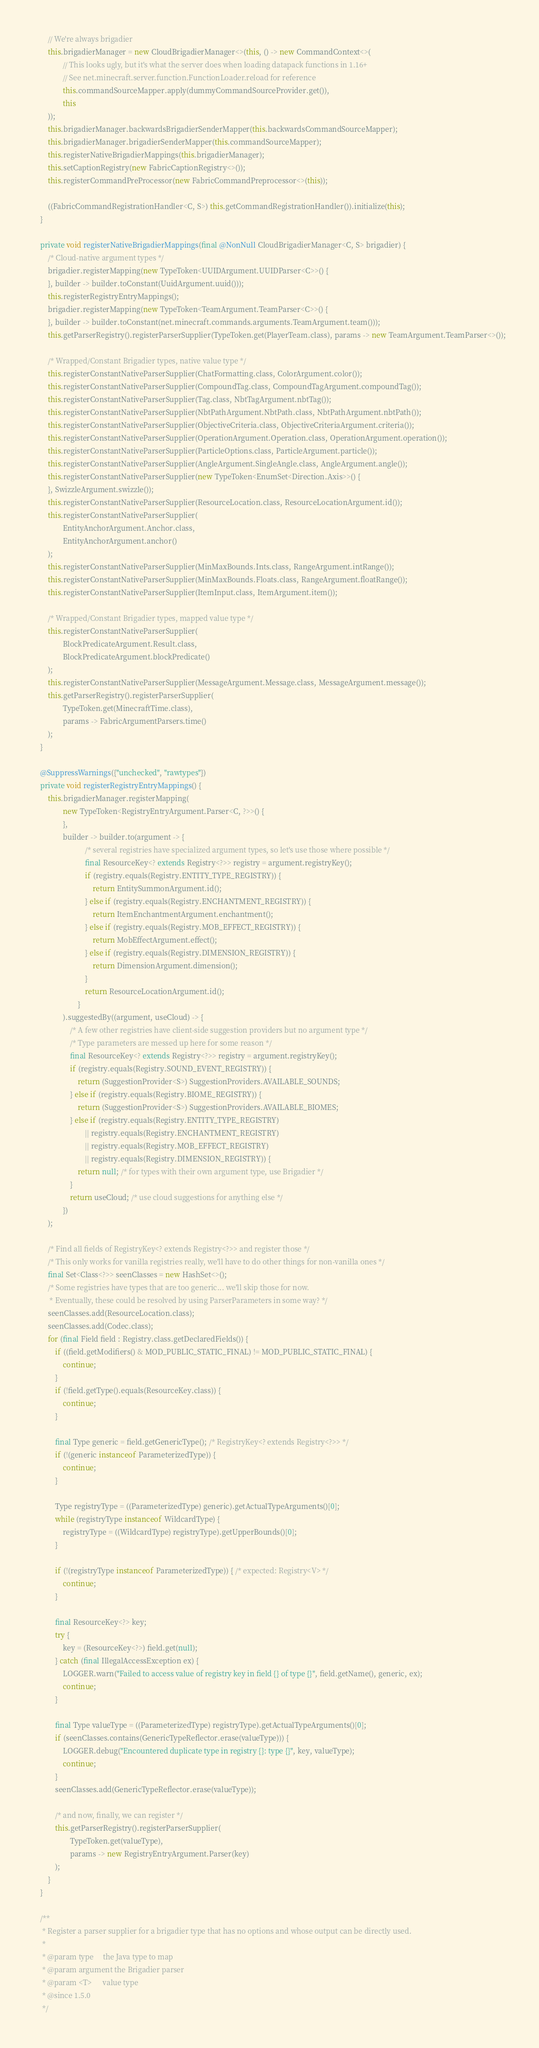Convert code to text. <code><loc_0><loc_0><loc_500><loc_500><_Java_>
        // We're always brigadier
        this.brigadierManager = new CloudBrigadierManager<>(this, () -> new CommandContext<>(
                // This looks ugly, but it's what the server does when loading datapack functions in 1.16+
                // See net.minecraft.server.function.FunctionLoader.reload for reference
                this.commandSourceMapper.apply(dummyCommandSourceProvider.get()),
                this
        ));
        this.brigadierManager.backwardsBrigadierSenderMapper(this.backwardsCommandSourceMapper);
        this.brigadierManager.brigadierSenderMapper(this.commandSourceMapper);
        this.registerNativeBrigadierMappings(this.brigadierManager);
        this.setCaptionRegistry(new FabricCaptionRegistry<>());
        this.registerCommandPreProcessor(new FabricCommandPreprocessor<>(this));

        ((FabricCommandRegistrationHandler<C, S>) this.getCommandRegistrationHandler()).initialize(this);
    }

    private void registerNativeBrigadierMappings(final @NonNull CloudBrigadierManager<C, S> brigadier) {
        /* Cloud-native argument types */
        brigadier.registerMapping(new TypeToken<UUIDArgument.UUIDParser<C>>() {
        }, builder -> builder.toConstant(UuidArgument.uuid()));
        this.registerRegistryEntryMappings();
        brigadier.registerMapping(new TypeToken<TeamArgument.TeamParser<C>>() {
        }, builder -> builder.toConstant(net.minecraft.commands.arguments.TeamArgument.team()));
        this.getParserRegistry().registerParserSupplier(TypeToken.get(PlayerTeam.class), params -> new TeamArgument.TeamParser<>());

        /* Wrapped/Constant Brigadier types, native value type */
        this.registerConstantNativeParserSupplier(ChatFormatting.class, ColorArgument.color());
        this.registerConstantNativeParserSupplier(CompoundTag.class, CompoundTagArgument.compoundTag());
        this.registerConstantNativeParserSupplier(Tag.class, NbtTagArgument.nbtTag());
        this.registerConstantNativeParserSupplier(NbtPathArgument.NbtPath.class, NbtPathArgument.nbtPath());
        this.registerConstantNativeParserSupplier(ObjectiveCriteria.class, ObjectiveCriteriaArgument.criteria());
        this.registerConstantNativeParserSupplier(OperationArgument.Operation.class, OperationArgument.operation());
        this.registerConstantNativeParserSupplier(ParticleOptions.class, ParticleArgument.particle());
        this.registerConstantNativeParserSupplier(AngleArgument.SingleAngle.class, AngleArgument.angle());
        this.registerConstantNativeParserSupplier(new TypeToken<EnumSet<Direction.Axis>>() {
        }, SwizzleArgument.swizzle());
        this.registerConstantNativeParserSupplier(ResourceLocation.class, ResourceLocationArgument.id());
        this.registerConstantNativeParserSupplier(
                EntityAnchorArgument.Anchor.class,
                EntityAnchorArgument.anchor()
        );
        this.registerConstantNativeParserSupplier(MinMaxBounds.Ints.class, RangeArgument.intRange());
        this.registerConstantNativeParserSupplier(MinMaxBounds.Floats.class, RangeArgument.floatRange());
        this.registerConstantNativeParserSupplier(ItemInput.class, ItemArgument.item());

        /* Wrapped/Constant Brigadier types, mapped value type */
        this.registerConstantNativeParserSupplier(
                BlockPredicateArgument.Result.class,
                BlockPredicateArgument.blockPredicate()
        );
        this.registerConstantNativeParserSupplier(MessageArgument.Message.class, MessageArgument.message());
        this.getParserRegistry().registerParserSupplier(
                TypeToken.get(MinecraftTime.class),
                params -> FabricArgumentParsers.time()
        );
    }

    @SuppressWarnings({"unchecked", "rawtypes"})
    private void registerRegistryEntryMappings() {
        this.brigadierManager.registerMapping(
                new TypeToken<RegistryEntryArgument.Parser<C, ?>>() {
                },
                builder -> builder.to(argument -> {
                            /* several registries have specialized argument types, so let's use those where possible */
                            final ResourceKey<? extends Registry<?>> registry = argument.registryKey();
                            if (registry.equals(Registry.ENTITY_TYPE_REGISTRY)) {
                                return EntitySummonArgument.id();
                            } else if (registry.equals(Registry.ENCHANTMENT_REGISTRY)) {
                                return ItemEnchantmentArgument.enchantment();
                            } else if (registry.equals(Registry.MOB_EFFECT_REGISTRY)) {
                                return MobEffectArgument.effect();
                            } else if (registry.equals(Registry.DIMENSION_REGISTRY)) {
                                return DimensionArgument.dimension();
                            }
                            return ResourceLocationArgument.id();
                        }
                ).suggestedBy((argument, useCloud) -> {
                    /* A few other registries have client-side suggestion providers but no argument type */
                    /* Type parameters are messed up here for some reason */
                    final ResourceKey<? extends Registry<?>> registry = argument.registryKey();
                    if (registry.equals(Registry.SOUND_EVENT_REGISTRY)) {
                        return (SuggestionProvider<S>) SuggestionProviders.AVAILABLE_SOUNDS;
                    } else if (registry.equals(Registry.BIOME_REGISTRY)) {
                        return (SuggestionProvider<S>) SuggestionProviders.AVAILABLE_BIOMES;
                    } else if (registry.equals(Registry.ENTITY_TYPE_REGISTRY)
                            || registry.equals(Registry.ENCHANTMENT_REGISTRY)
                            || registry.equals(Registry.MOB_EFFECT_REGISTRY)
                            || registry.equals(Registry.DIMENSION_REGISTRY)) {
                        return null; /* for types with their own argument type, use Brigadier */
                    }
                    return useCloud; /* use cloud suggestions for anything else */
                })
        );

        /* Find all fields of RegistryKey<? extends Registry<?>> and register those */
        /* This only works for vanilla registries really, we'll have to do other things for non-vanilla ones */
        final Set<Class<?>> seenClasses = new HashSet<>();
        /* Some registries have types that are too generic... we'll skip those for now.
         * Eventually, these could be resolved by using ParserParameters in some way? */
        seenClasses.add(ResourceLocation.class);
        seenClasses.add(Codec.class);
        for (final Field field : Registry.class.getDeclaredFields()) {
            if ((field.getModifiers() & MOD_PUBLIC_STATIC_FINAL) != MOD_PUBLIC_STATIC_FINAL) {
                continue;
            }
            if (!field.getType().equals(ResourceKey.class)) {
                continue;
            }

            final Type generic = field.getGenericType(); /* RegistryKey<? extends Registry<?>> */
            if (!(generic instanceof ParameterizedType)) {
                continue;
            }

            Type registryType = ((ParameterizedType) generic).getActualTypeArguments()[0];
            while (registryType instanceof WildcardType) {
                registryType = ((WildcardType) registryType).getUpperBounds()[0];
            }

            if (!(registryType instanceof ParameterizedType)) { /* expected: Registry<V> */
                continue;
            }

            final ResourceKey<?> key;
            try {
                key = (ResourceKey<?>) field.get(null);
            } catch (final IllegalAccessException ex) {
                LOGGER.warn("Failed to access value of registry key in field {} of type {}", field.getName(), generic, ex);
                continue;
            }

            final Type valueType = ((ParameterizedType) registryType).getActualTypeArguments()[0];
            if (seenClasses.contains(GenericTypeReflector.erase(valueType))) {
                LOGGER.debug("Encountered duplicate type in registry {}: type {}", key, valueType);
                continue;
            }
            seenClasses.add(GenericTypeReflector.erase(valueType));

            /* and now, finally, we can register */
            this.getParserRegistry().registerParserSupplier(
                    TypeToken.get(valueType),
                    params -> new RegistryEntryArgument.Parser(key)
            );
        }
    }

    /**
     * Register a parser supplier for a brigadier type that has no options and whose output can be directly used.
     *
     * @param type     the Java type to map
     * @param argument the Brigadier parser
     * @param <T>      value type
     * @since 1.5.0
     */</code> 